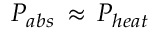Convert formula to latex. <formula><loc_0><loc_0><loc_500><loc_500>P _ { a b s } \, \approx \, P _ { h e a t }</formula> 